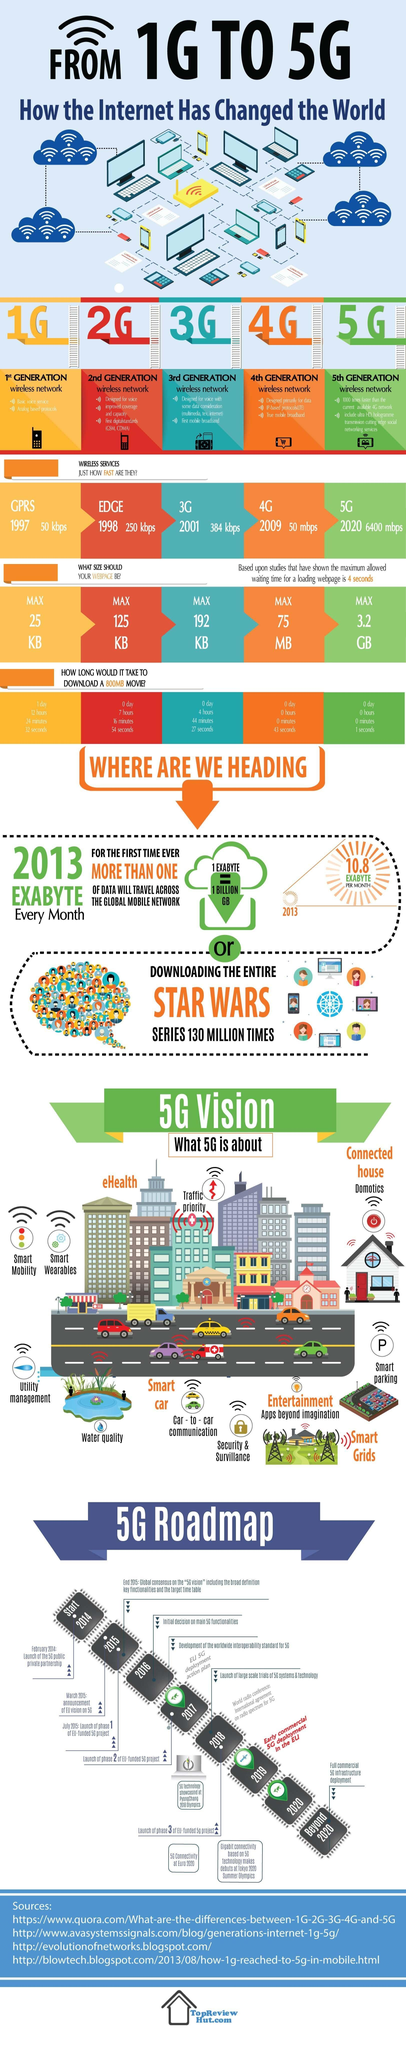What is the maximum download speed of 5G network?
Answer the question with a short phrase. 3.2 GB Which wireless network has the highest speed? 5G When was the third generation wireless network launched? 2001 What is the speed of 4G network? 50 mbps What is the speed of GPRS network? 50 kbps When was the 2G wireless network launched? 1998 When was the fifth generation wireless network launched? 2020 What is the maximum download speed of 4G network? 75 MB 